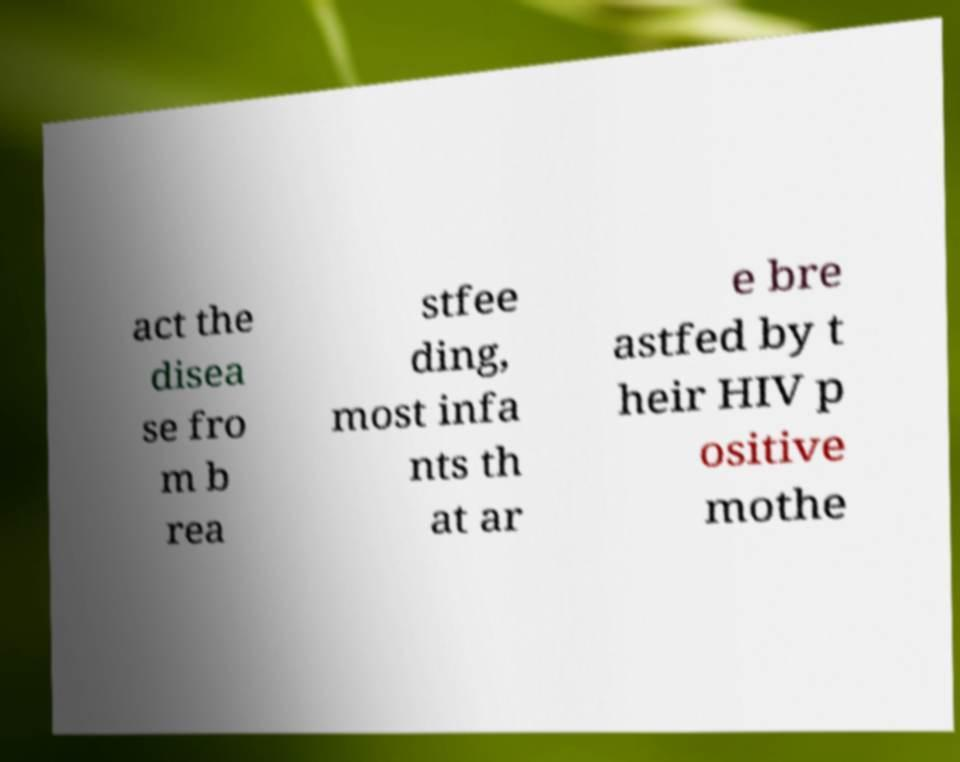Please read and relay the text visible in this image. What does it say? act the disea se fro m b rea stfee ding, most infa nts th at ar e bre astfed by t heir HIV p ositive mothe 